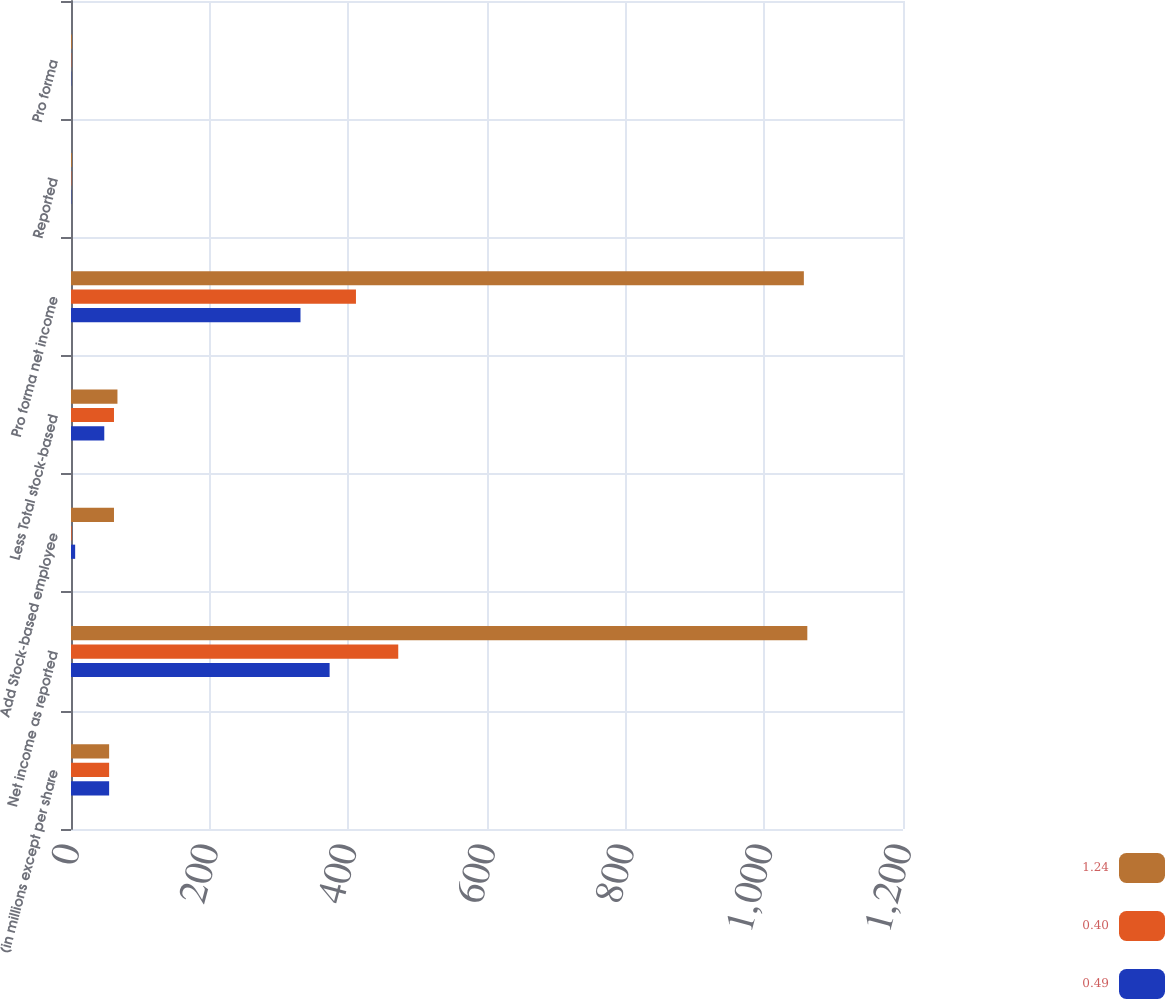Convert chart to OTSL. <chart><loc_0><loc_0><loc_500><loc_500><stacked_bar_chart><ecel><fcel>(in millions except per share<fcel>Net income as reported<fcel>Add Stock-based employee<fcel>Less Total stock-based<fcel>Pro forma net income<fcel>Reported<fcel>Pro forma<nl><fcel>1.24<fcel>55<fcel>1062<fcel>62<fcel>67<fcel>1057<fcel>1.27<fcel>1.26<nl><fcel>0.4<fcel>55<fcel>472<fcel>1<fcel>62<fcel>411<fcel>0.57<fcel>0.5<nl><fcel>0.49<fcel>55<fcel>373<fcel>6<fcel>48<fcel>331<fcel>0.46<fcel>0.41<nl></chart> 